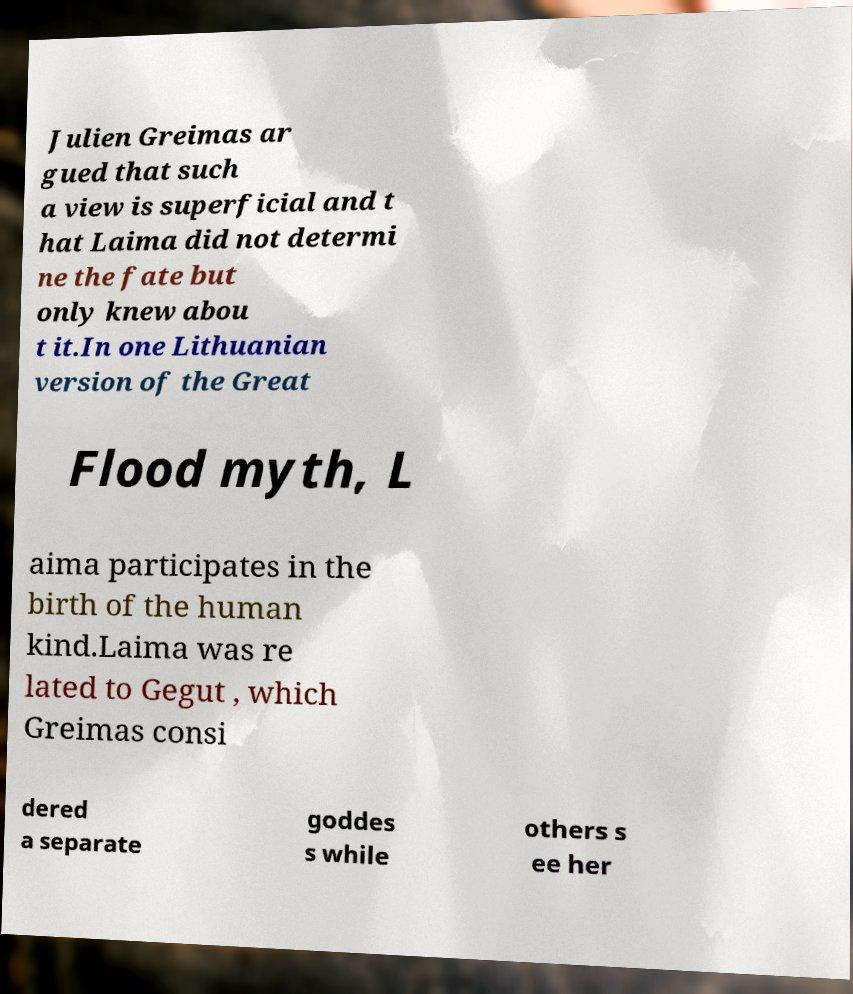Can you read and provide the text displayed in the image?This photo seems to have some interesting text. Can you extract and type it out for me? Julien Greimas ar gued that such a view is superficial and t hat Laima did not determi ne the fate but only knew abou t it.In one Lithuanian version of the Great Flood myth, L aima participates in the birth of the human kind.Laima was re lated to Gegut , which Greimas consi dered a separate goddes s while others s ee her 